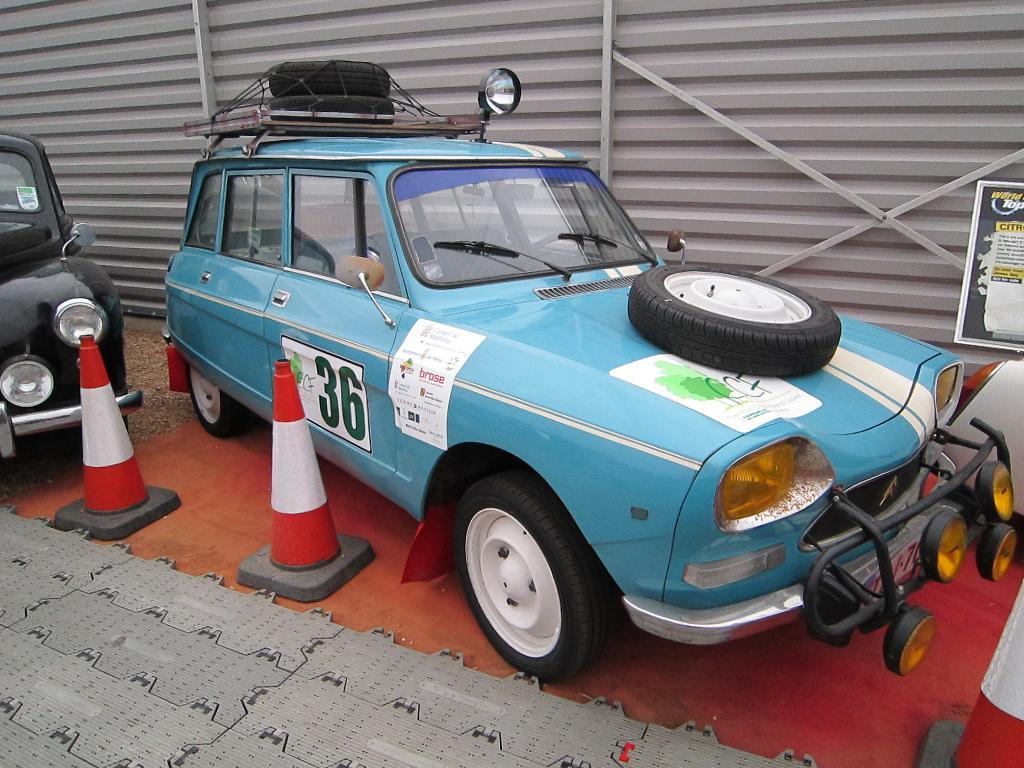How many vehicles are in the image? There are two vehicles in the image. What are the colors of the vehicles? One vehicle is blue, and the other is black. What else can be seen in the image besides the vehicles? There are two poles in the image. What are the colors of the poles? One pole is red, and the other is white. What other object can be seen in the image? There is a wheel in the image, and it is black. How does the image show an increase in wealth? The image does not show an increase in wealth; it depicts vehicles, poles, and a wheel. 